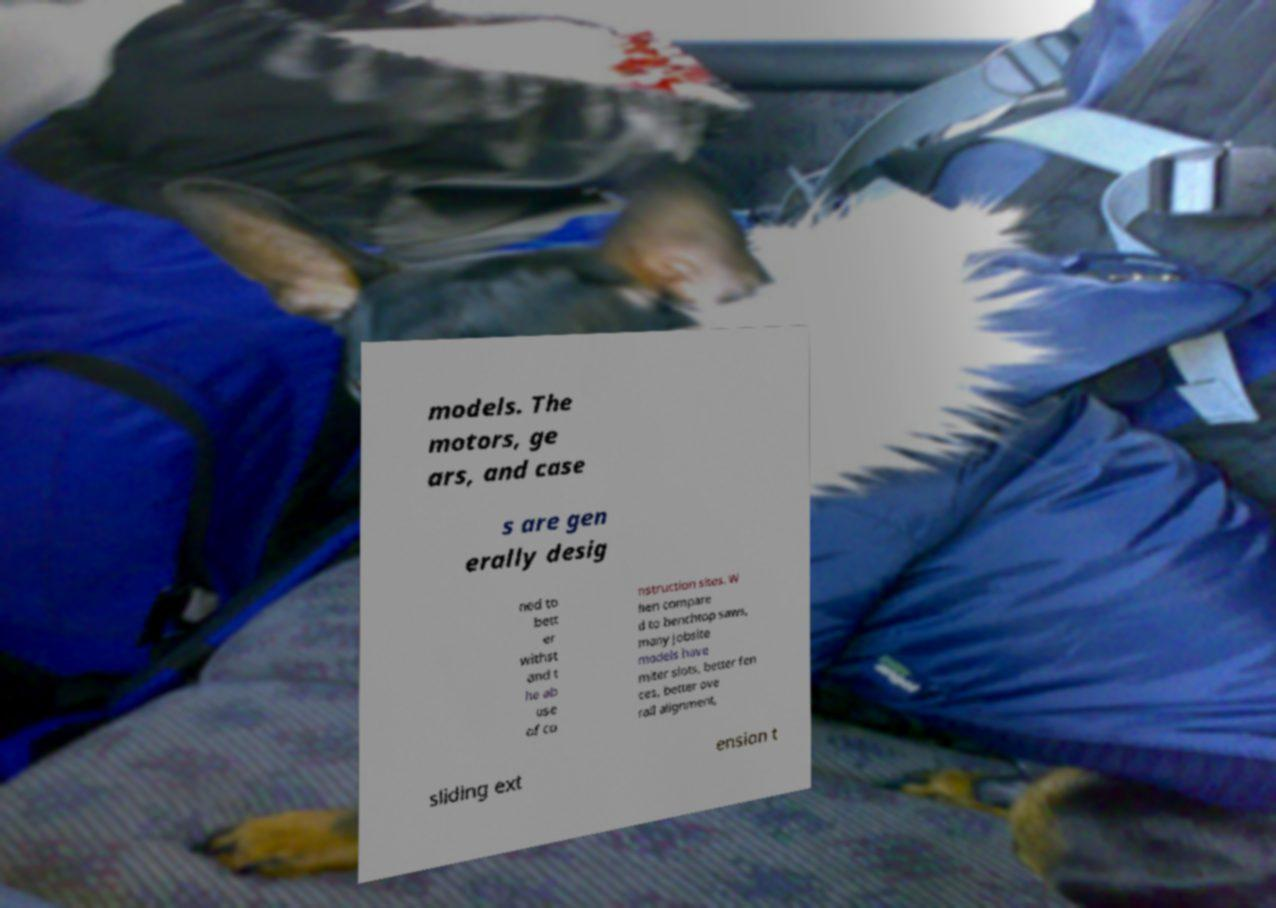Can you read and provide the text displayed in the image?This photo seems to have some interesting text. Can you extract and type it out for me? models. The motors, ge ars, and case s are gen erally desig ned to bett er withst and t he ab use of co nstruction sites. W hen compare d to benchtop saws, many jobsite models have miter slots, better fen ces, better ove rall alignment, sliding ext ension t 